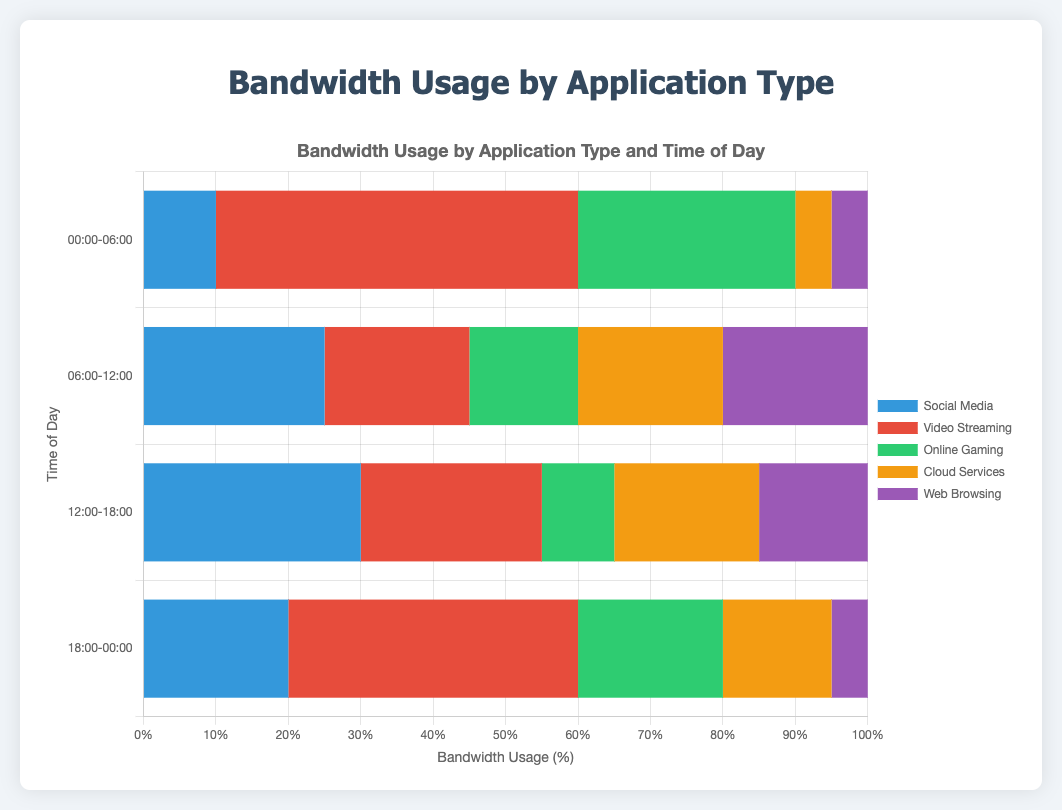What time of day has the highest total bandwidth usage? Add up the usage values for each time of day and compare them. For 00:00-06:00, the total usage is 10 + 50 + 30 + 5 + 5 = 100. For 06:00-12:00, it is 25 + 20 + 15 + 20 + 20 = 100. For 12:00-18:00, it is 30 + 25 + 10 + 20 + 15 = 100. For 18:00-00:00, it is 20 + 40 + 20 + 15 + 5 = 100. Since they are all equal, no single time of day has the highest total bandwidth usage.
Answer: All equal Between Social Media and Online Gaming, which application uses more bandwidth during 12:00-18:00? Compare the values for Social Media and Online Gaming during the 12:00-18:00 time slot. Social Media usage is 30, and Online Gaming usage is 10.
Answer: Social Media What is the total bandwidth usage for Cloud Services and Web Browsing combined during 06:00-12:00? Add the values for Cloud Services and Web Browsing during the 06:00-12:00 time slot. For Cloud Services, it is 20, and for Web Browsing, it is 20. So, the combined usage is 20 + 20 = 40.
Answer: 40 Across all time slots, which application has the least total bandwidth usage? Sum the usage for each application across all time slots and compare. Social Media: 10 + 25 + 30 + 20 = 85, Video Streaming: 50 + 20 + 25 + 40 = 135, Online Gaming: 30 + 15 + 10 + 20 = 75, Cloud Services: 5 + 20 + 20 + 15 = 60, Web Browsing: 5 + 20 + 15 + 5 = 45. Comparatively, Web Browsing has the least total bandwidth usage.
Answer: Web Browsing How does the bandwidth usage for Video Streaming during 00:00-06:00 compare to Online Gaming during the same period? Compare the values for Video Streaming and Online Gaming during the 00:00-06:00 time slot. The value for Video Streaming is 50, and for Online Gaming, it is 30.
Answer: Video Streaming is higher Which time slot shows the least bandwidth usage for Web Browsing? Compare the Web Browsing values across all time slots: 00:00-06:00 (5), 06:00-12:00 (20), 12:00-18:00 (15), 18:00-00:00 (5). The least bandwidth usage occurs at 00:00-06:00 and 18:00-00:00 where it is 5.
Answer: 00:00-06:00 and 18:00-00:00 During which time slot is the usage of Social Media highest? Compare the Social Media values across all time slots: 00:00-06:00 (10), 06:00-12:00 (25), 12:00-18:00 (30), 18:00-00:00 (20). The highest value is 30 at 12:00-18:00.
Answer: 12:00-18:00 What is the average bandwidth usage for Online Gaming across all time slots? Sum the Online Gaming values across all time slots and then divide by the number of time slots. The values are 30, 15, 10, and 20. The sum is 30 + 15 + 10 + 20 = 75. There are 4 time slots. Thus, the average is 75 / 4 = 18.75.
Answer: 18.75 